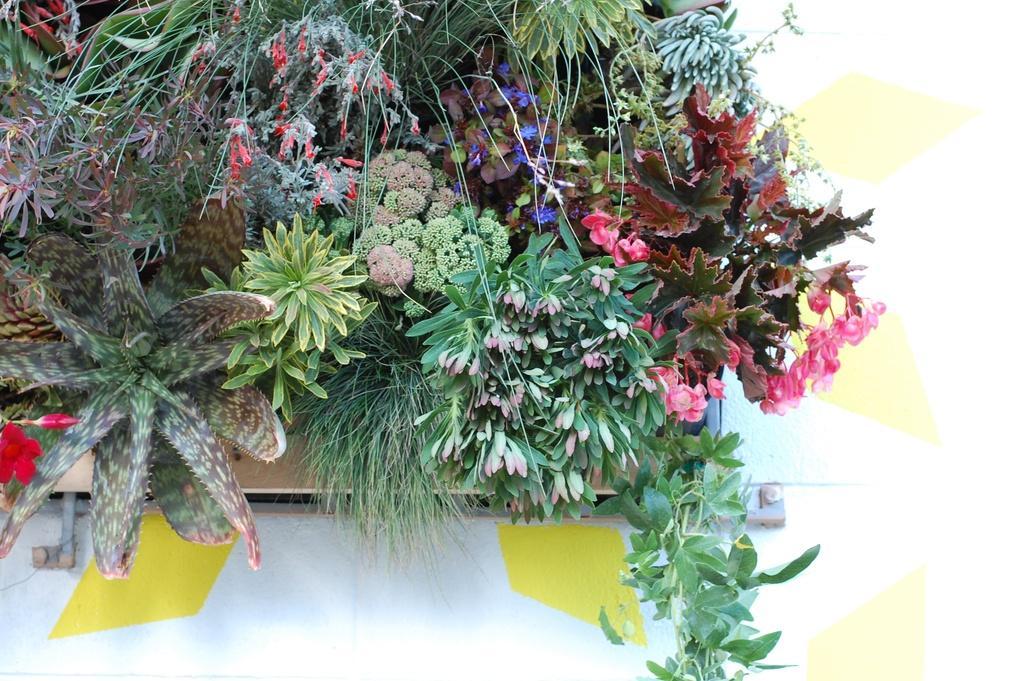Please provide a concise description of this image. In this image, we can see pants and flowers in the flower pot and at the bottom, there is table. 